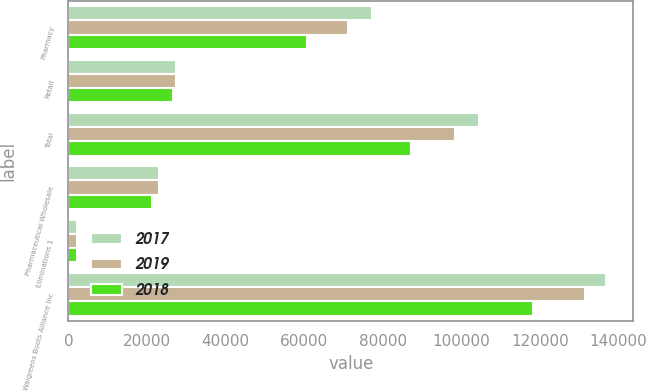Convert chart to OTSL. <chart><loc_0><loc_0><loc_500><loc_500><stacked_bar_chart><ecel><fcel>Pharmacy<fcel>Retail<fcel>Total<fcel>Pharmaceutical Wholesale<fcel>Eliminations 1<fcel>Walgreens Boots Alliance Inc<nl><fcel>2017<fcel>77192<fcel>27340<fcel>104532<fcel>23053<fcel>2180<fcel>136866<nl><fcel>2019<fcel>71055<fcel>27337<fcel>98392<fcel>23006<fcel>2142<fcel>131537<nl><fcel>2018<fcel>60608<fcel>26695<fcel>87302<fcel>21188<fcel>2089<fcel>118214<nl></chart> 